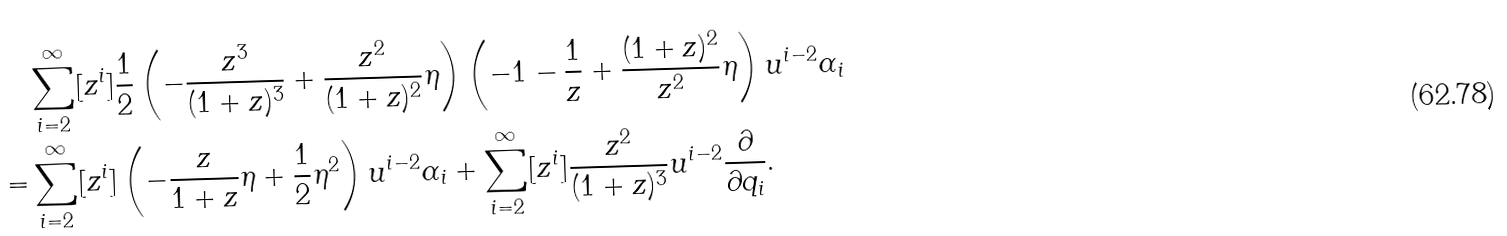<formula> <loc_0><loc_0><loc_500><loc_500>& \sum _ { i = 2 } ^ { \infty } [ z ^ { i } ] \frac { 1 } { 2 } \left ( - \frac { z ^ { 3 } } { ( 1 + z ) ^ { 3 } } + \frac { z ^ { 2 } } { ( 1 + z ) ^ { 2 } } \eta \right ) \left ( - 1 - \frac { 1 } { z } + \frac { ( 1 + z ) ^ { 2 } } { z ^ { 2 } } \eta \right ) u ^ { i - 2 } \alpha _ { i } \\ = & \sum _ { i = 2 } ^ { \infty } [ z ^ { i } ] \left ( - \frac { z } { 1 + z } \eta + \frac { 1 } { 2 } \eta ^ { 2 } \right ) u ^ { i - 2 } \alpha _ { i } + \sum _ { i = 2 } ^ { \infty } [ z ^ { i } ] \frac { z ^ { 2 } } { ( 1 + z ) ^ { 3 } } u ^ { i - 2 } \frac { \partial } { \partial q _ { i } } .</formula> 